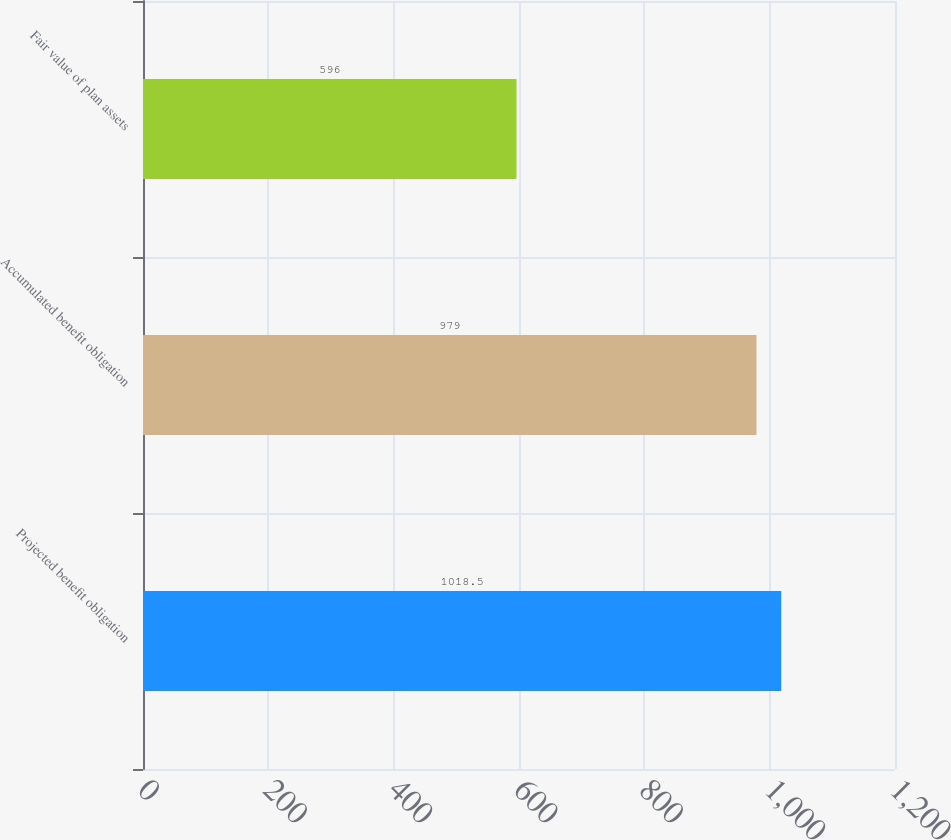Convert chart. <chart><loc_0><loc_0><loc_500><loc_500><bar_chart><fcel>Projected benefit obligation<fcel>Accumulated benefit obligation<fcel>Fair value of plan assets<nl><fcel>1018.5<fcel>979<fcel>596<nl></chart> 